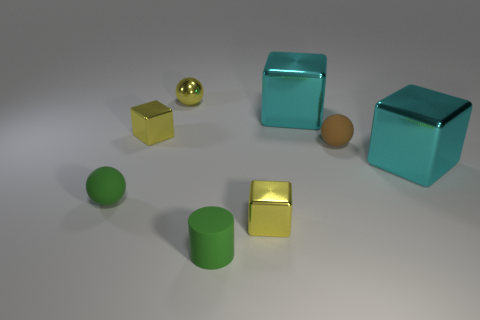How many blue matte objects have the same shape as the brown object?
Offer a terse response. 0. What material is the tiny object that is both behind the tiny green sphere and to the right of the yellow metal sphere?
Offer a terse response. Rubber. What number of tiny yellow things are in front of the small green ball?
Give a very brief answer. 1. What number of big metal things are there?
Provide a short and direct response. 2. Is the size of the yellow sphere the same as the brown rubber sphere?
Make the answer very short. Yes. Is there a green object that is in front of the yellow shiny block to the right of the tiny yellow metallic sphere that is behind the brown thing?
Give a very brief answer. Yes. What is the material of the small green thing that is the same shape as the small brown rubber thing?
Ensure brevity in your answer.  Rubber. What color is the matte thing right of the small cylinder?
Your answer should be compact. Brown. What is the size of the yellow metal ball?
Keep it short and to the point. Small. There is a yellow metal ball; is its size the same as the yellow metallic block that is behind the tiny green sphere?
Your answer should be very brief. Yes. 